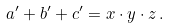Convert formula to latex. <formula><loc_0><loc_0><loc_500><loc_500>a ^ { \prime } + b ^ { \prime } + c ^ { \prime } = x \cdot y \cdot z \, .</formula> 